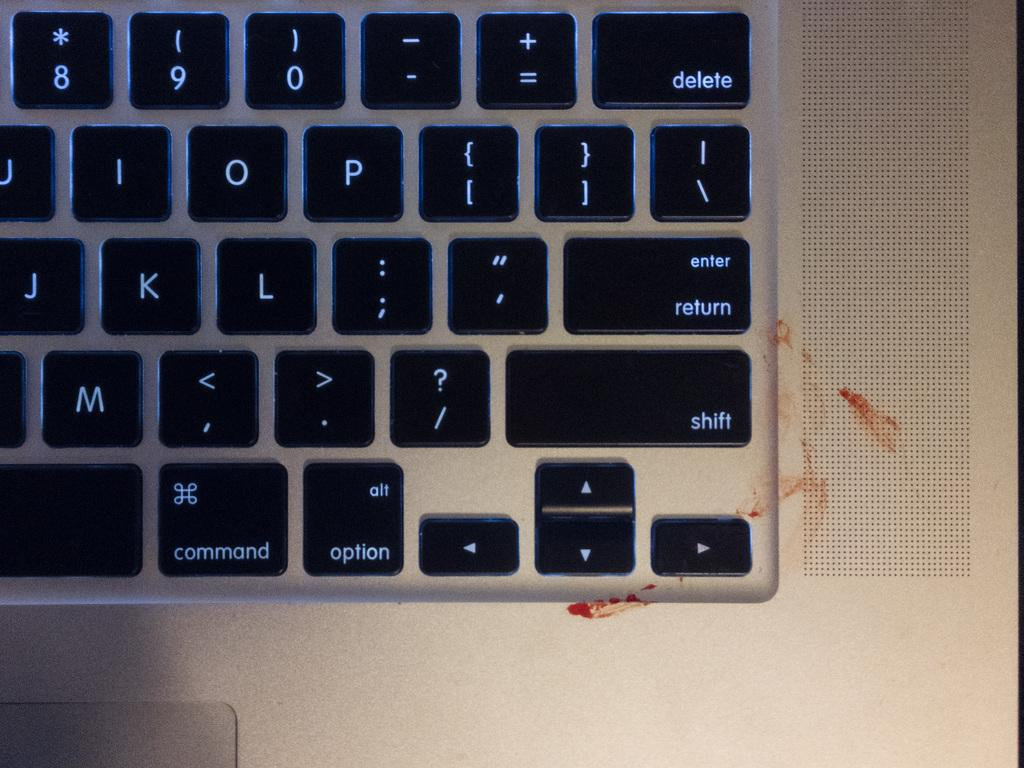Provide a one-sentence caption for the provided image. a keyboard with backlit keys including j k and l. 